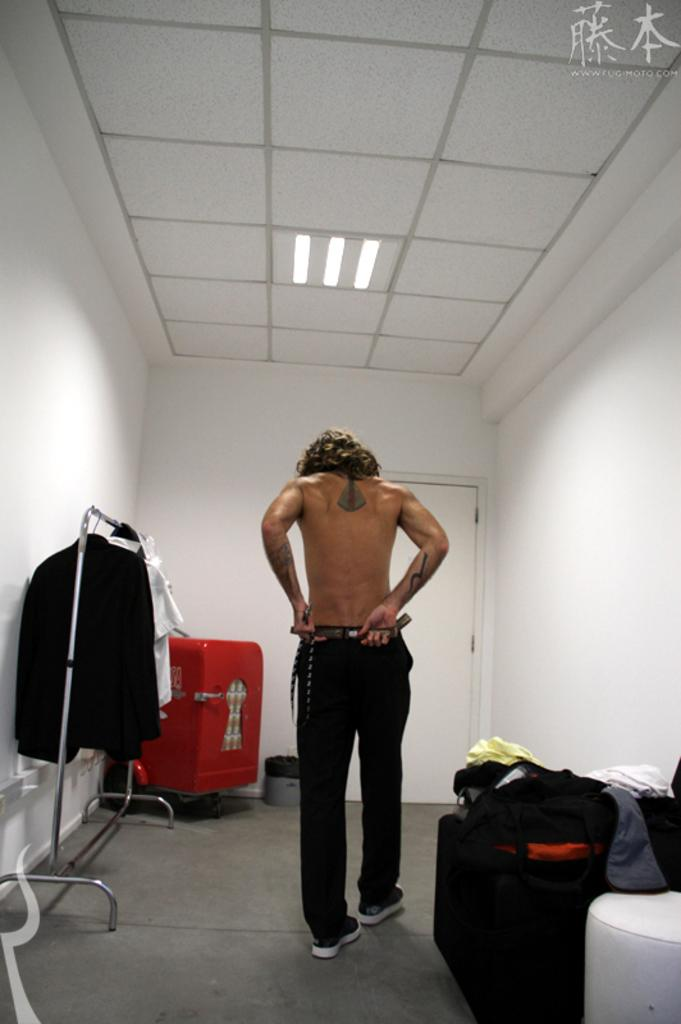What is the primary subject in the image? There is a person standing in the image. Where is the person standing? The person is standing on the floor. What type of material is present in the image? Cloths are present in the image. What architectural feature can be seen in the image? There is a door in the image. What part of the room is visible in the image? The ceiling and walls are visible in the image. What provides illumination in the image? Lights are present in the image. What else can be seen in the image besides the person and the cloths? There are objects in the image. What type of pear is being used as a pillow for the person in the image? There is no pear present in the image, and the person is not using any object as a pillow. 